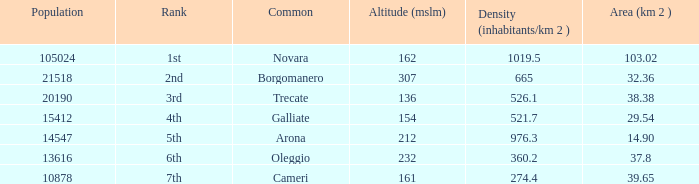Which common has an area (km2) of 38.38? Trecate. 